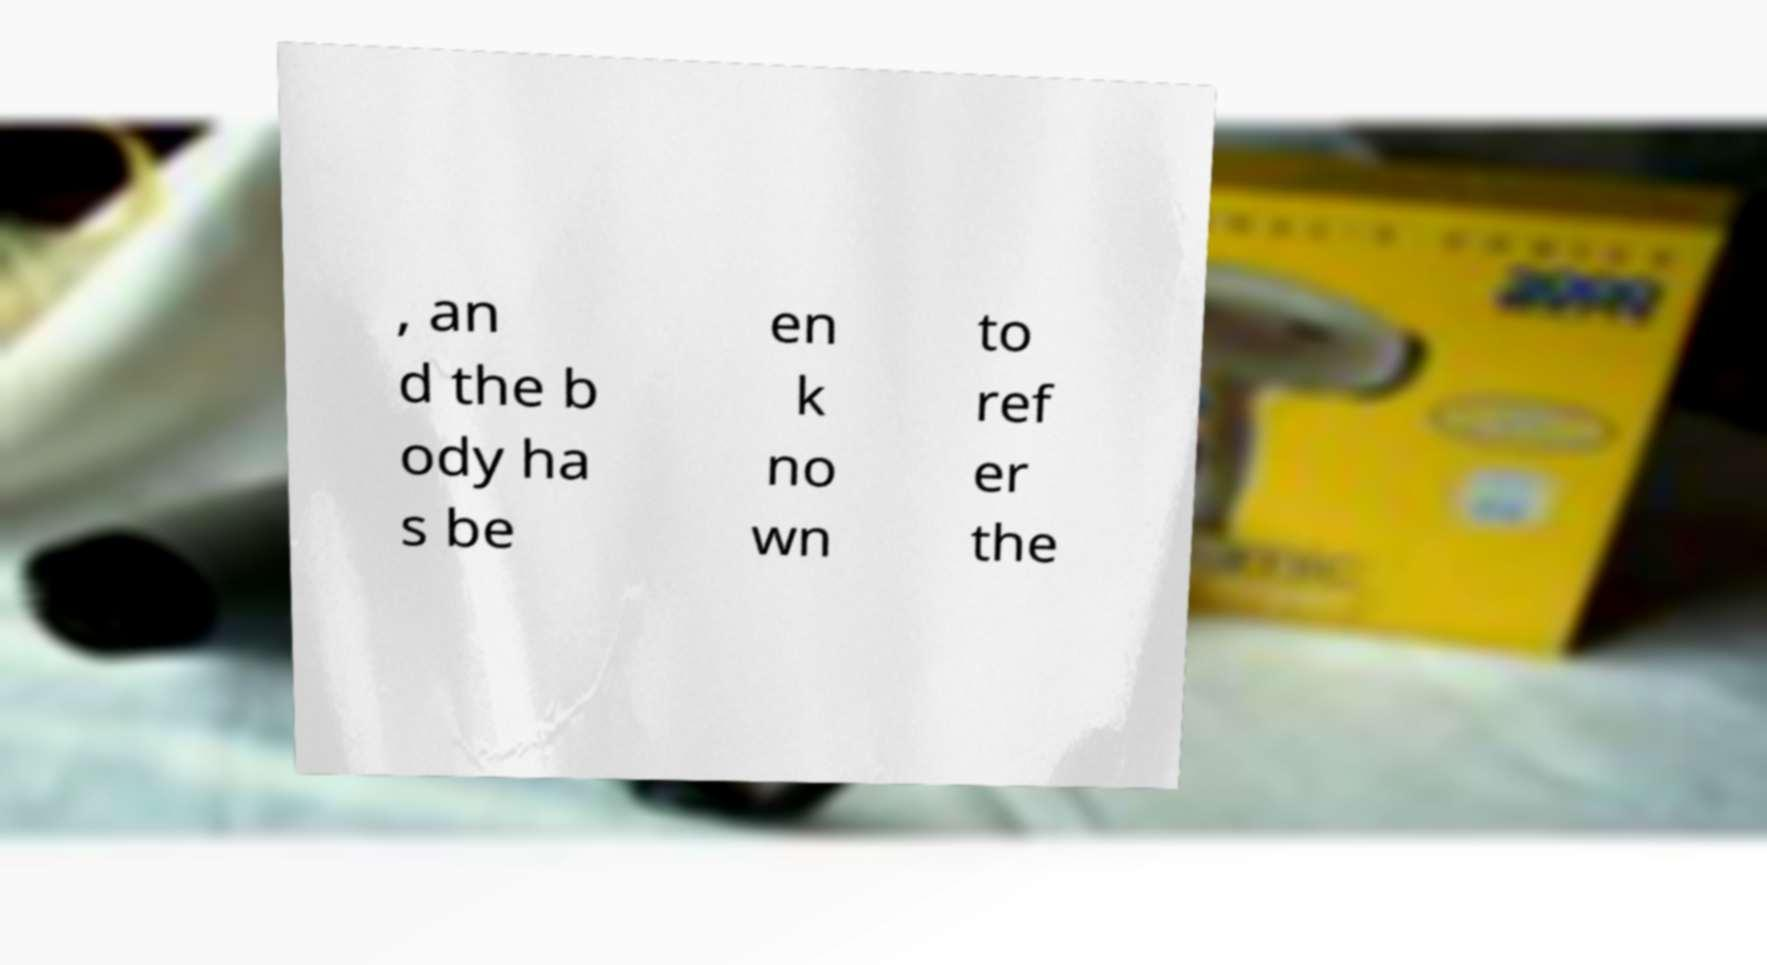Please identify and transcribe the text found in this image. , an d the b ody ha s be en k no wn to ref er the 